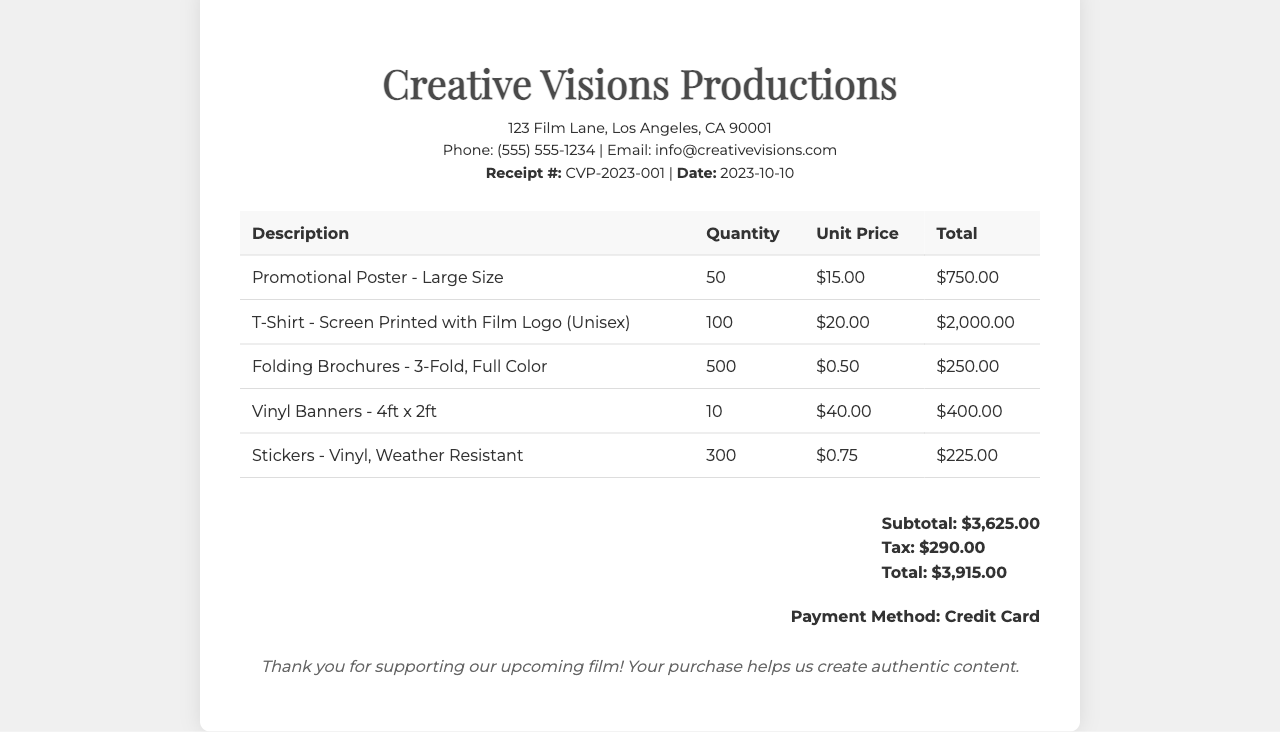What is the total quantity of T-Shirts purchased? The total quantity of T-Shirts listed in the document is 100.
Answer: 100 What is the cost of one large promotional poster? The unit price for one large promotional poster is stated as $15.00.
Answer: $15.00 How much is the total amount spent on stickers? The total for the stickers, calculated as 300 stickers at $0.75 each, is $225.00.
Answer: $225.00 What is the subtotal of the merchandise before tax? The subtotal before tax reflects the sum of all items, which is $3,625.00.
Answer: $3,625.00 What is the date on this receipt? The date mentioned in the document is 2023-10-10.
Answer: 2023-10-10 How many vinyl banners were purchased? The document indicates that 10 vinyl banners were purchased.
Answer: 10 What method of payment was used for this purchase? The payment method indicated on the receipt is Credit Card.
Answer: Credit Card What is the tax amount included in the total? The tax amount noted in the document is $290.00.
Answer: $290.00 How many folding brochures were included in the order? The order includes 500 folding brochures.
Answer: 500 